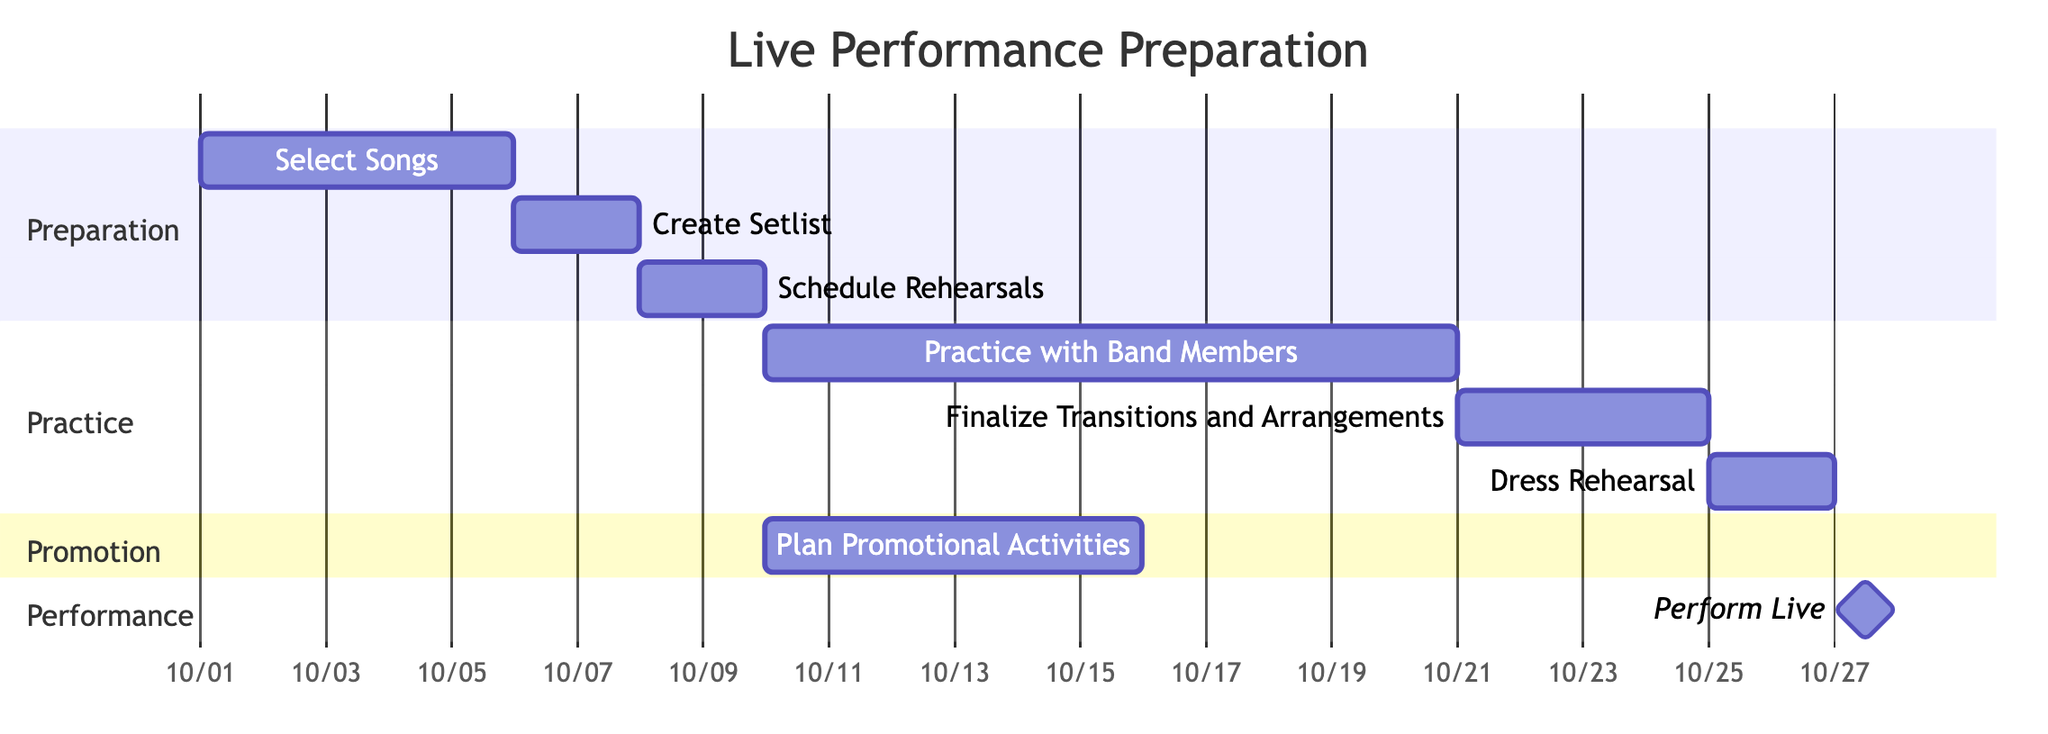What is the first task listed in the Gantt chart? The first task listed is "Select Songs," which appears at the top of the preparation section of the chart.
Answer: Select Songs How many total tasks are represented in the Gantt chart? By counting each task listed under the different sections (Preparation, Practice, Promotion, and Performance), there are a total of eight tasks.
Answer: Eight What is the end date for the "Dress Rehearsal" task? The "Dress Rehearsal" task ends on the date provided in the chart, which is 2023-10-26.
Answer: 2023-10-26 What task starts on the same day as "Practice with Band Members"? "Plan Promotional Activities" starts on the same day, which is 2023-10-10, as indicated in the chart.
Answer: Plan Promotional Activities Which task follows "Schedule Rehearsals"? The task that follows "Schedule Rehearsals" is "Practice with Band Members," as seen in the flow from the preparation section to the practice section.
Answer: Practice with Band Members How many days does the "Select Songs" task take? The "Select Songs" task takes 5 days, as indicated in the chart showing its duration from 2023-10-01 to 2023-10-05.
Answer: Five days What is the duration of the "Practice with Band Members" task? The duration of the "Practice with Band Members" task is 11 days, running from 2023-10-10 to 2023-10-20.
Answer: Eleven days What task is marked as a milestone in the chart? The "Perform Live" task is marked as a milestone, which is a significant single-event indicator in the chart.
Answer: Perform Live Which task is scheduled to occur immediately after the "Finalize Transitions and Arrangements"? The "Dress Rehearsal" task is scheduled to occur immediately after the "Finalize Transitions and Arrangements," as it follows directly in the timeline.
Answer: Dress Rehearsal 